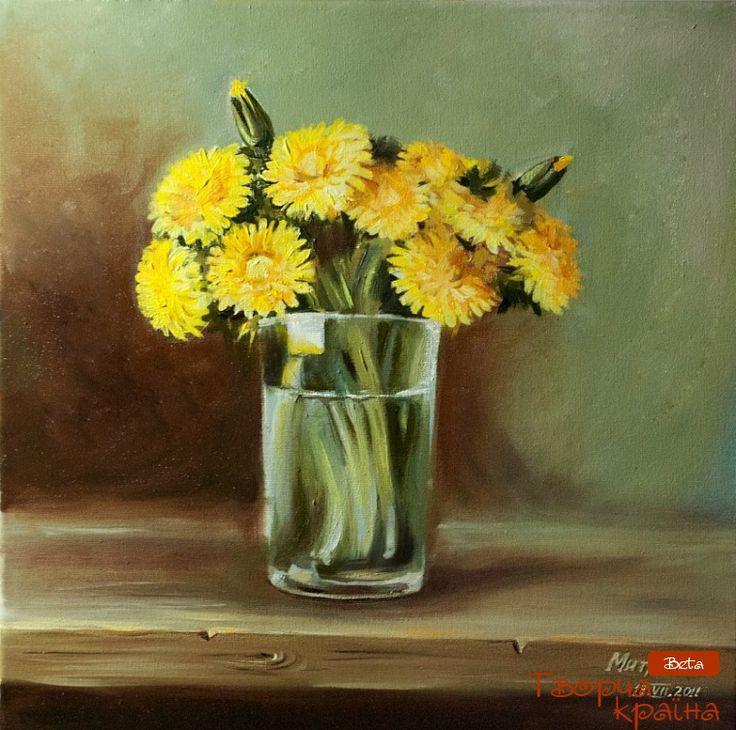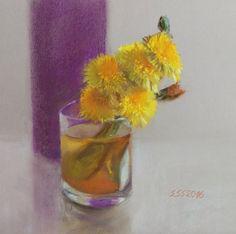The first image is the image on the left, the second image is the image on the right. For the images shown, is this caption "The white vase is filled with yellow flowers." true? Answer yes or no. No. 